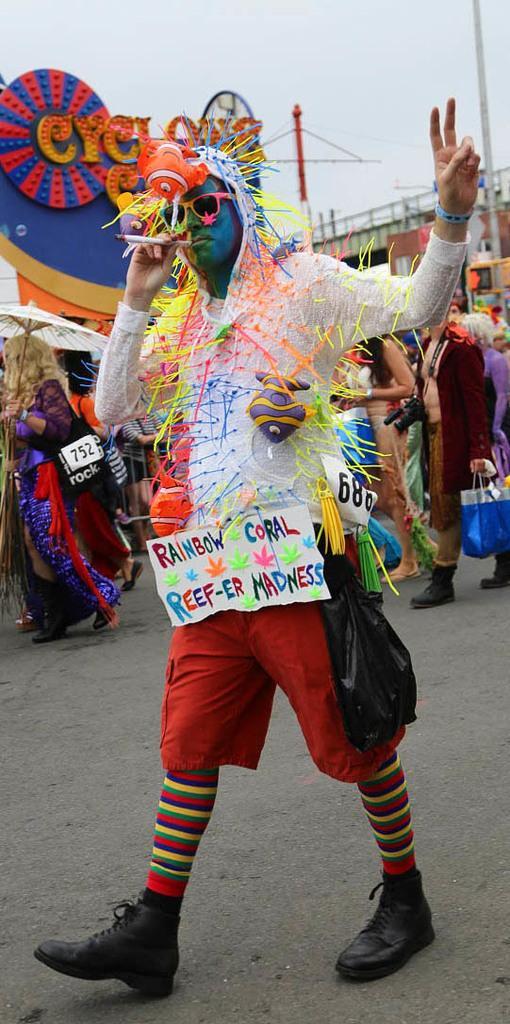In one or two sentences, can you explain what this image depicts? In this image I can see a person in fancy dress and he is holding an object. Also in the background there are group of people with fancy dresses, there are some objects and there is sky. 